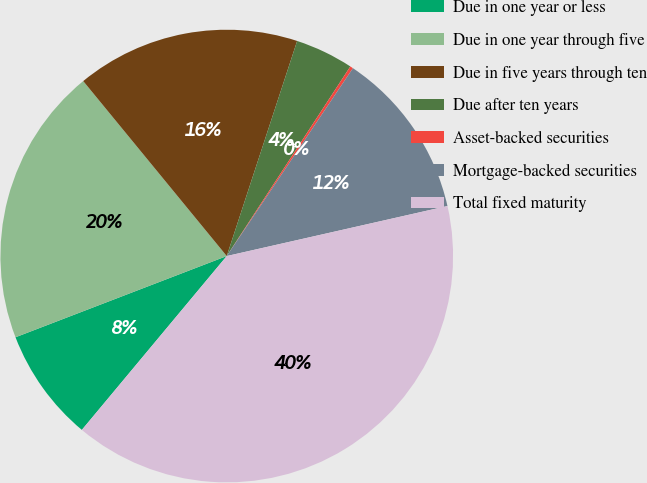Convert chart. <chart><loc_0><loc_0><loc_500><loc_500><pie_chart><fcel>Due in one year or less<fcel>Due in one year through five<fcel>Due in five years through ten<fcel>Due after ten years<fcel>Asset-backed securities<fcel>Mortgage-backed securities<fcel>Total fixed maturity<nl><fcel>8.1%<fcel>19.91%<fcel>15.97%<fcel>4.16%<fcel>0.22%<fcel>12.04%<fcel>39.61%<nl></chart> 